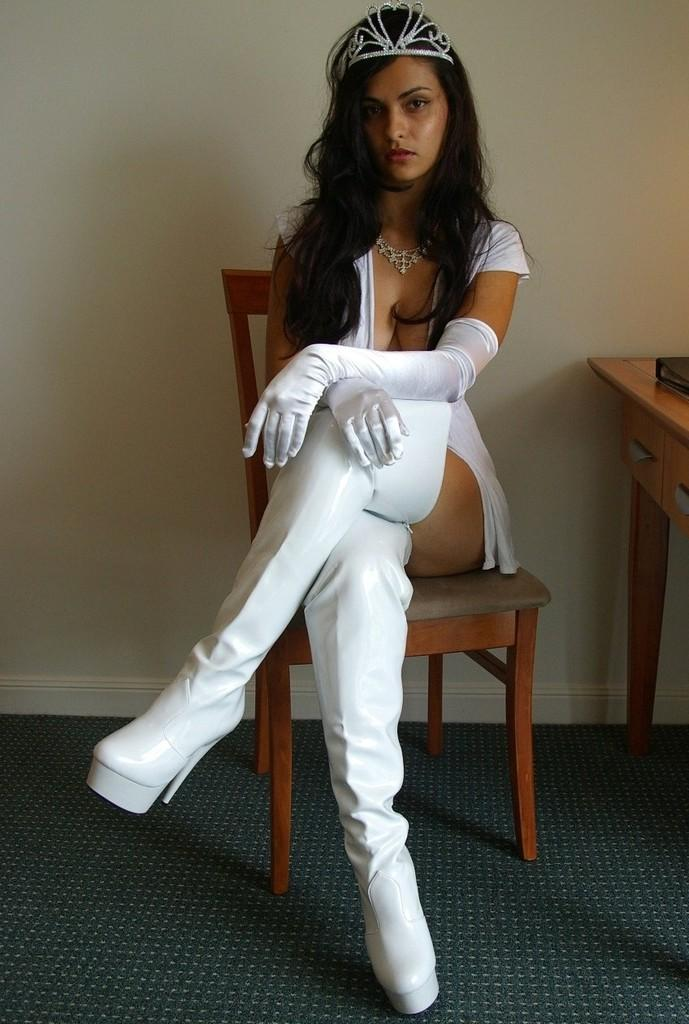Who is present in the image? There is a woman in the picture. What is the woman doing in the image? The woman is sitting on a chair. What other object can be seen in the image? There is a table in the picture. What type of tree can be seen behind the woman in the image? There is no tree visible in the image; it only features a woman sitting on a chair and a table. 